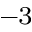<formula> <loc_0><loc_0><loc_500><loc_500>^ { - 3 }</formula> 